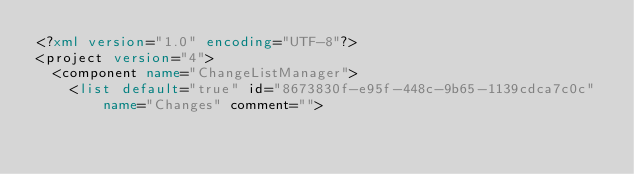Convert code to text. <code><loc_0><loc_0><loc_500><loc_500><_XML_><?xml version="1.0" encoding="UTF-8"?>
<project version="4">
  <component name="ChangeListManager">
    <list default="true" id="8673830f-e95f-448c-9b65-1139cdca7c0c" name="Changes" comment=""></code> 